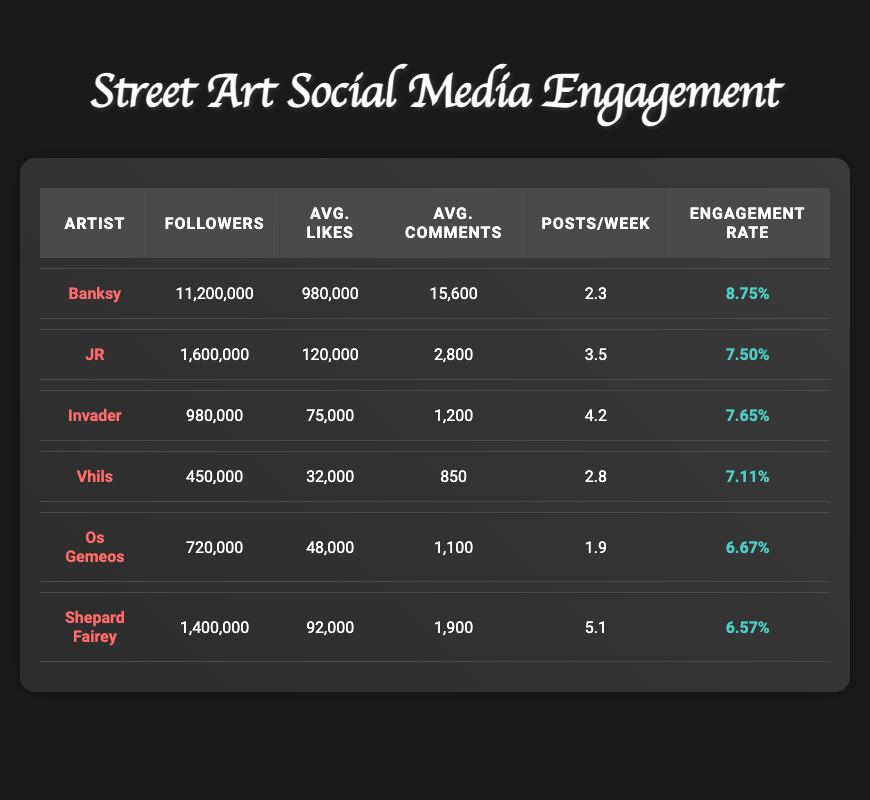What is the engagement rate of Banksy? The engagement rate for Banksy is provided directly in the table, at 8.75%.
Answer: 8.75% Which artist has the highest average likes per post? The average likes per post for Banksy is 980,000, which is higher than all other artists listed in the table.
Answer: Banksy What is the total number of average comments per post across all artists? To find the total, we add the average comments per post for each artist: 15,600 + 2,800 + 1,200 + 850 + 1,100 + 1,900 = 23,450
Answer: 23,450 Is the engagement rate of JR greater than that of Shepard Fairey? JR has an engagement rate of 7.5% while Shepard Fairey has an engagement rate of 6.57%, so the statement is true.
Answer: Yes What is the difference in followers between Banksy and Os Gemeos? Banksy has 11,200,000 followers and Os Gemeos has 720,000 followers. The difference is 11,200,000 - 720,000 = 10,480,000.
Answer: 10,480,000 If we calculate the average posts per week for all listed artists, what do we get? To find the average, we sum the posts per week and divide by the number of artists: (2.3 + 3.5 + 4.2 + 2.8 + 1.9 + 5.1) / 6 = 3.33
Answer: 3.33 Does Invader have more followers than Vhils? Invader has 980,000 followers and Vhils has 450,000 followers. Therefore, Invader has more followers.
Answer: Yes What is the artist with the least followers? Vhils has 450,000 followers, which is less than all the other artists listed.
Answer: Vhils How many total average likes do Banksy and Shepard Fairey have combined? The total average likes for Banksy (980,000) and Shepard Fairey (92,000) combined is 980,000 + 92,000 = 1,072,000.
Answer: 1,072,000 